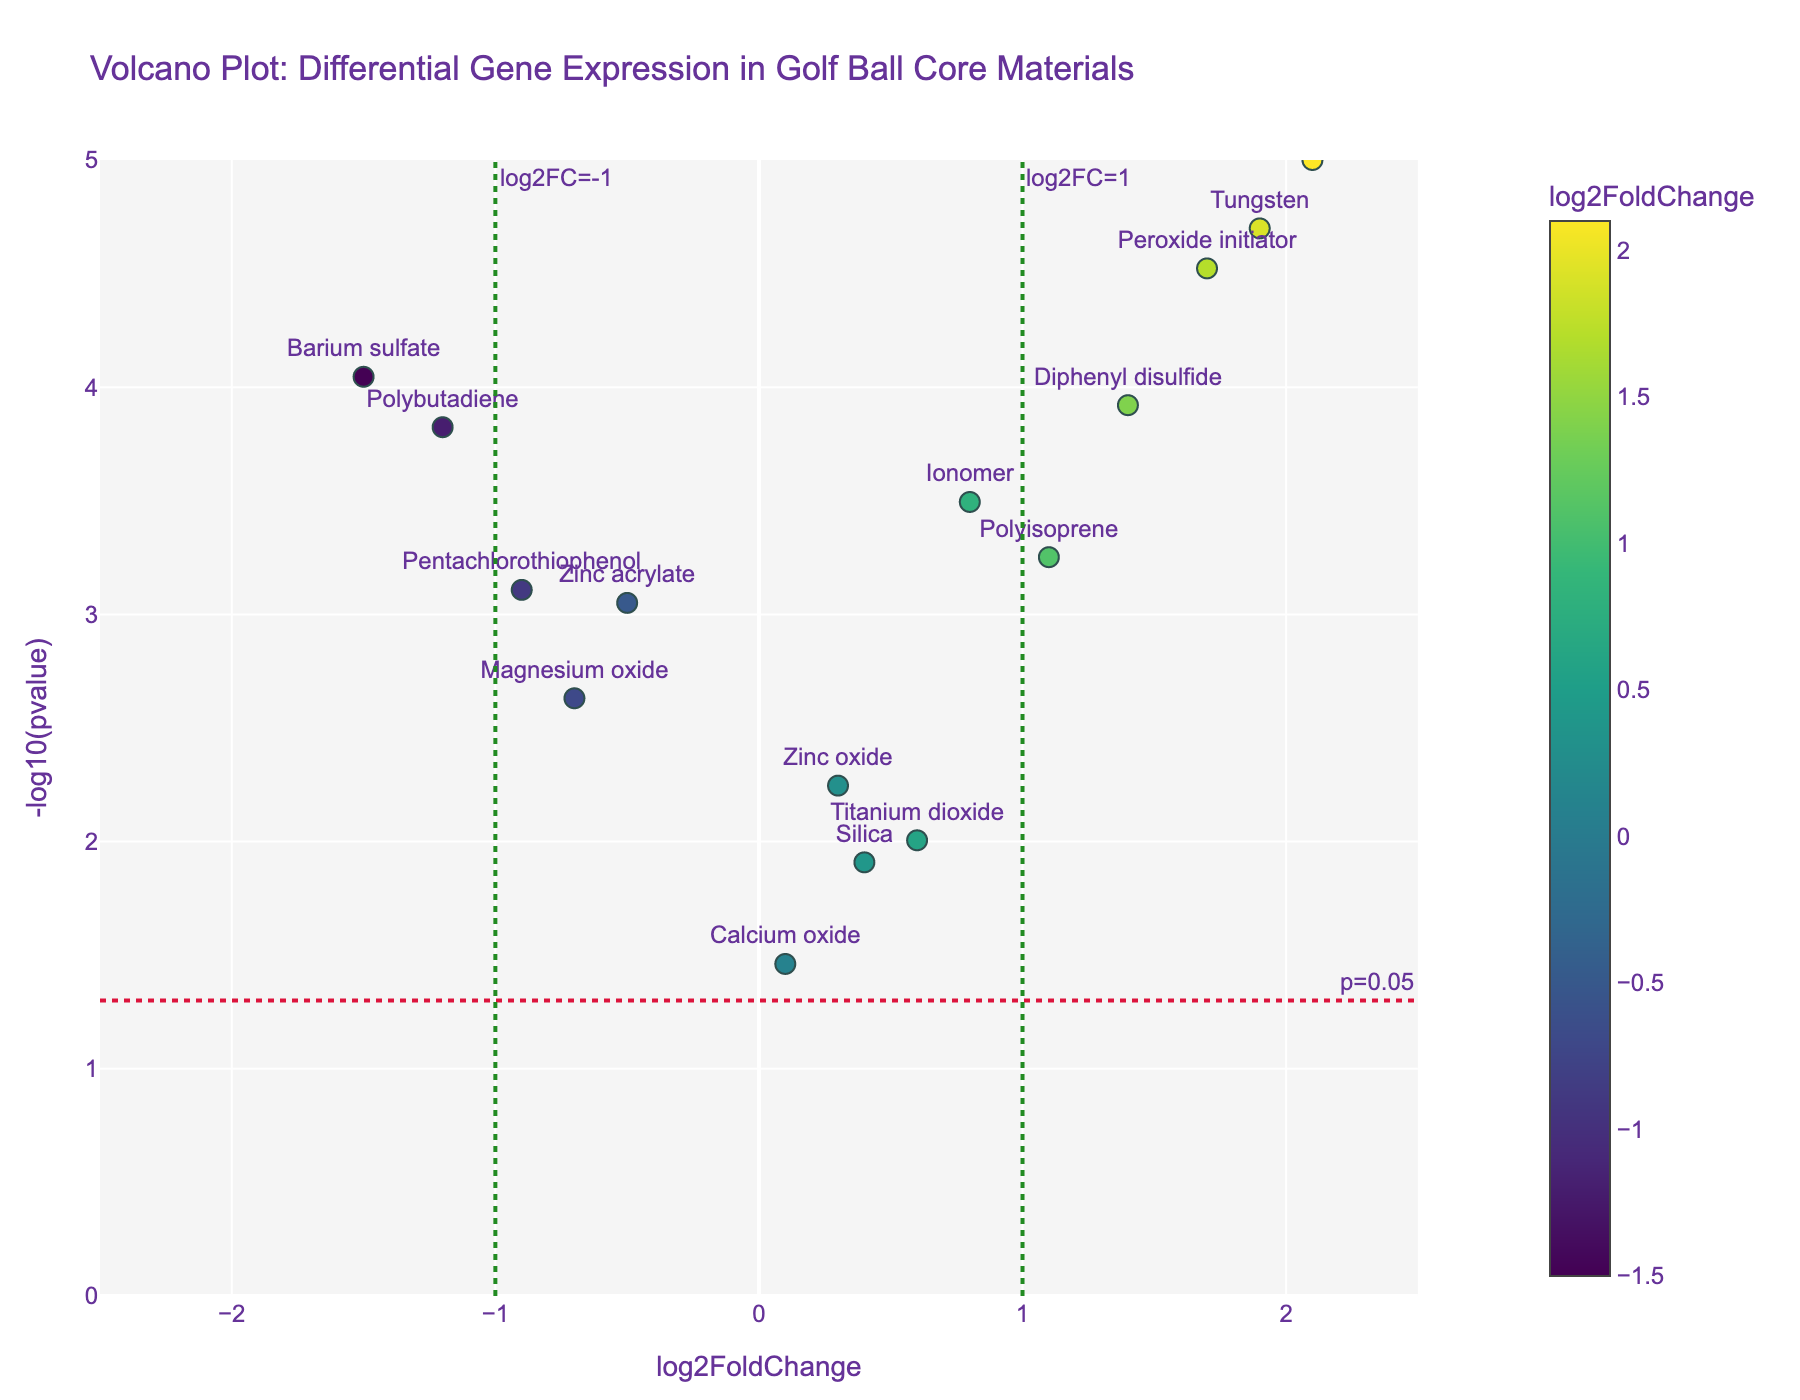What's the title of the plot? The title of the plot is typically found at the top and is a descriptive text summarizing what the plot represents. In this case, it reads "Volcano Plot: Differential Gene Expression in Golf Ball Core Materials".
Answer: Volcano Plot: Differential Gene Expression in Golf Ball Core Materials What do the x-axis and y-axis represent? The x-axis represents the log2FoldChange, which indicates the fold change in expression levels between two conditions on a logarithmic scale. The y-axis represents -log10(pvalue), which shows the significance of the change; higher values indicate higher significance.
Answer: x-axis: log2FoldChange, y-axis: -log10(pvalue) How many data points are there in the plot? By counting the number of markers or data points in the volcano plot, we find there are a total of 15 points, each representing a different gene or material used in golf ball cores.
Answer: 15 Which material has the highest log2FoldChange value, and what is this value? By locating the material with the furthest right position on the x-axis, we identify "Urethane" as having the highest log2FoldChange value. The x-axis position indicates this value is approximately 2.1.
Answer: Urethane, 2.1 Which material has the most significant p-value, and what is this value? The y-axis (representing -log10(pvalue)) helps identify the most significant p-value. The tallest point, indicating the highest significance, is "Urethane" with a p-value of approximately 0.00001 (displayed as -log10(pvalue) of 5).
Answer: Urethane, 0.00001 What materials have a log2FoldChange greater than 1 and are statistically significant (p < 0.05)? Materials that meet the criteria are found to the right of the vertical line at log2FoldChange = 1 and above the horizontal line at -log10(pvalue) = 1.3 (representing p < 0.05). These materials are "Urethane," "Peroxide initiator," "Diphenyl disulfide," "Tungsten," and "Polyisoprene."
Answer: Urethane, Peroxide initiator, Diphenyl disulfide, Tungsten, Polyisoprene Which material is closest to the intersection of log2FoldChange = 0 and p = 0.05? The closest data point to the coordinate (0, 1.3) in the plot is "Calcium oxide," which has values very near these intersections.
Answer: Calcium oxide What is the range of -log10(pvalue) in the plot? The range of -log10(pvalue) is determined by the smallest and largest values on the y-axis. From the plot, it ranges from just above 0 to approximately 5.
Answer: Just above 0 to 5 Compare the log2FoldChange values of "Polybutadiene" and "Barium sulfate". Which one has a lower value? By identifying their positions on the x-axis, "Polybutadiene" is at -1.2, and "Barium sulfate" is at -1.5, indicating that "Barium sulfate" has a lower log2FoldChange value.
Answer: Barium sulfate Explain the significance lines plotted on the figure and what they represent. The significance lines indicate thresholds for interpretation. The horizontal red dashed line at -log10(pvalue) = 1.3 corresponds to a p-value of 0.05, indicating statistical significance. The vertical green dashed lines at log2FoldChange = 1 and -1 indicate practical significance thresholds for upregulation and downregulation, respectively.
Answer: Thresholds for p-value = 0.05 and log2FoldChange = ±1 